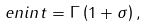Convert formula to latex. <formula><loc_0><loc_0><loc_500><loc_500>\ e n i n t = \Gamma \left ( 1 + \sigma \right ) ,</formula> 